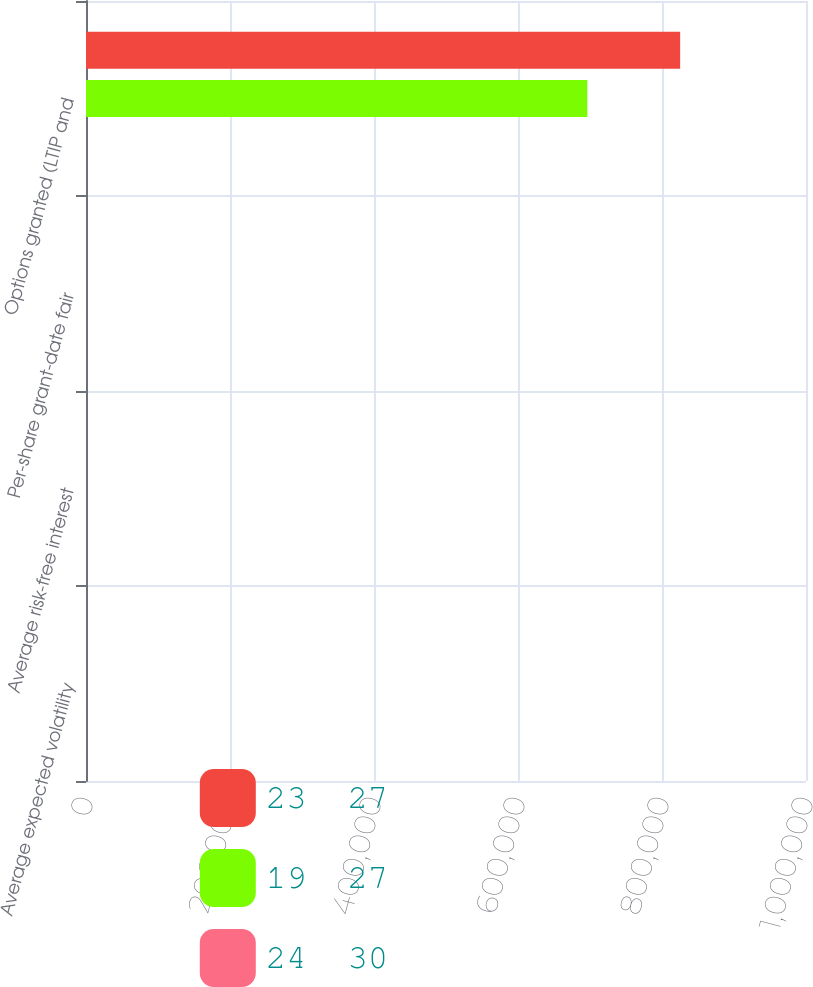Convert chart. <chart><loc_0><loc_0><loc_500><loc_500><stacked_bar_chart><ecel><fcel>Average expected volatility<fcel>Average risk-free interest<fcel>Per-share grant-date fair<fcel>Options granted (LTIP and<nl><fcel>23  27<fcel>25<fcel>1.83<fcel>24.71<fcel>825210<nl><fcel>19  27<fcel>25<fcel>2.79<fcel>24.38<fcel>696310<nl><fcel>24  30<fcel>26<fcel>1.88<fcel>15.84<fcel>24.855<nl></chart> 